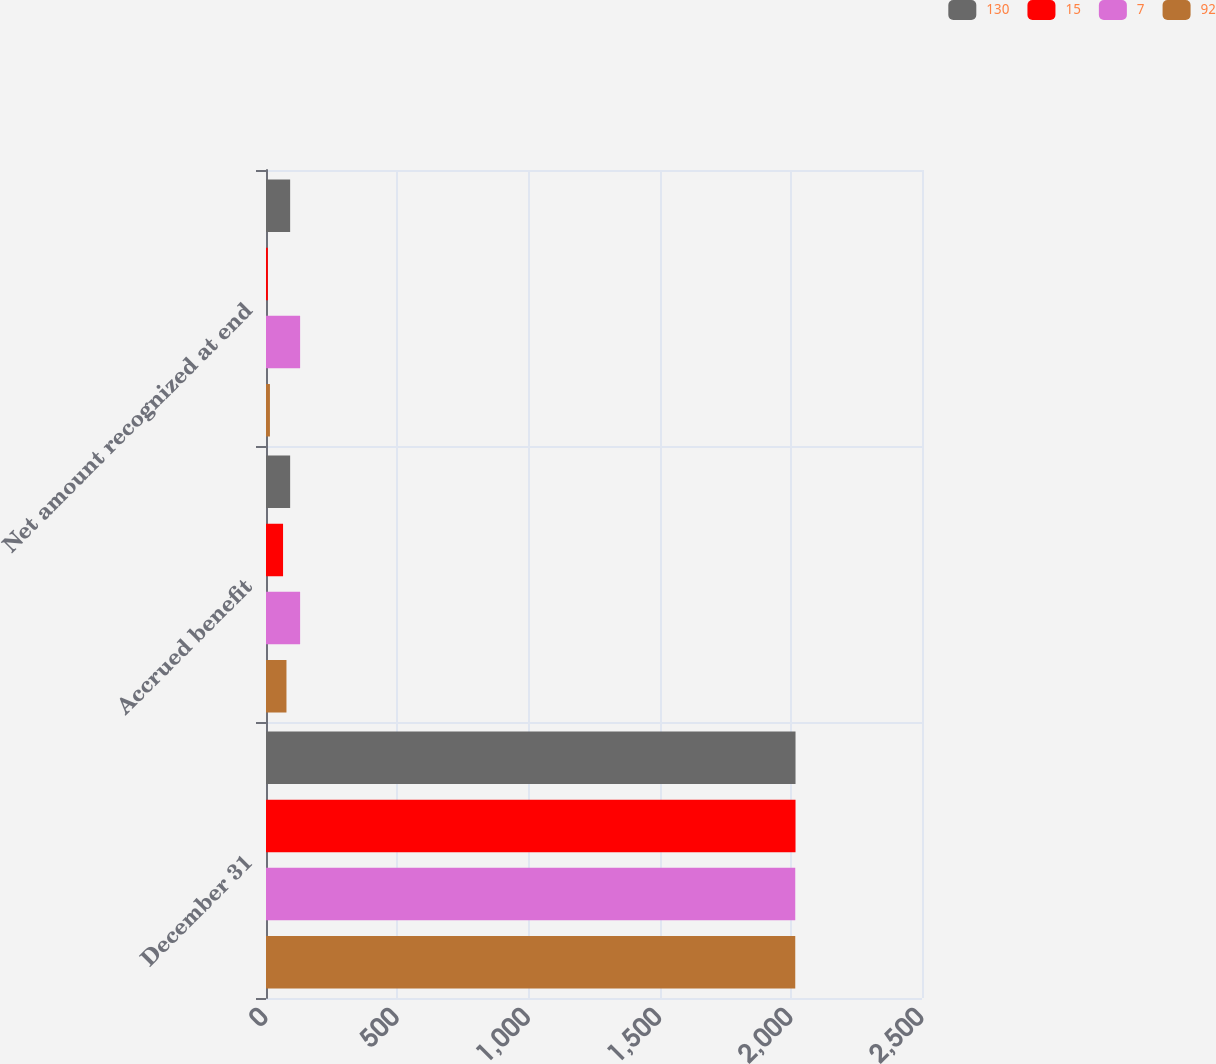Convert chart. <chart><loc_0><loc_0><loc_500><loc_500><stacked_bar_chart><ecel><fcel>December 31<fcel>Accrued benefit<fcel>Net amount recognized at end<nl><fcel>130<fcel>2018<fcel>92<fcel>92<nl><fcel>15<fcel>2018<fcel>65<fcel>7<nl><fcel>7<fcel>2017<fcel>130<fcel>130<nl><fcel>92<fcel>2017<fcel>78<fcel>15<nl></chart> 